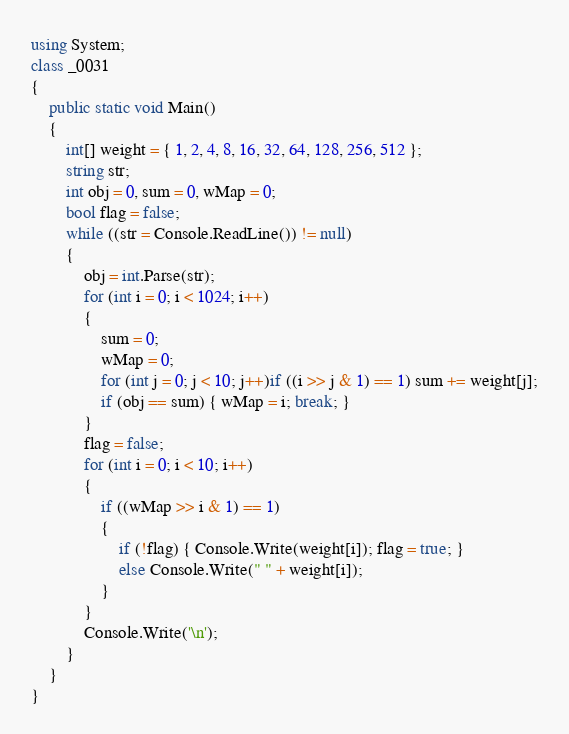<code> <loc_0><loc_0><loc_500><loc_500><_C#_>using System;
class _0031
{
    public static void Main()
    {
        int[] weight = { 1, 2, 4, 8, 16, 32, 64, 128, 256, 512 };
        string str;
        int obj = 0, sum = 0, wMap = 0;
        bool flag = false;
        while ((str = Console.ReadLine()) != null)
        {
            obj = int.Parse(str);
            for (int i = 0; i < 1024; i++)
            {
                sum = 0;
                wMap = 0;
                for (int j = 0; j < 10; j++)if ((i >> j & 1) == 1) sum += weight[j];
                if (obj == sum) { wMap = i; break; }
            }
            flag = false;
            for (int i = 0; i < 10; i++)
            {
                if ((wMap >> i & 1) == 1)
                {
                    if (!flag) { Console.Write(weight[i]); flag = true; }
                    else Console.Write(" " + weight[i]);
                }
            }
            Console.Write('\n');
        }
    }
}</code> 